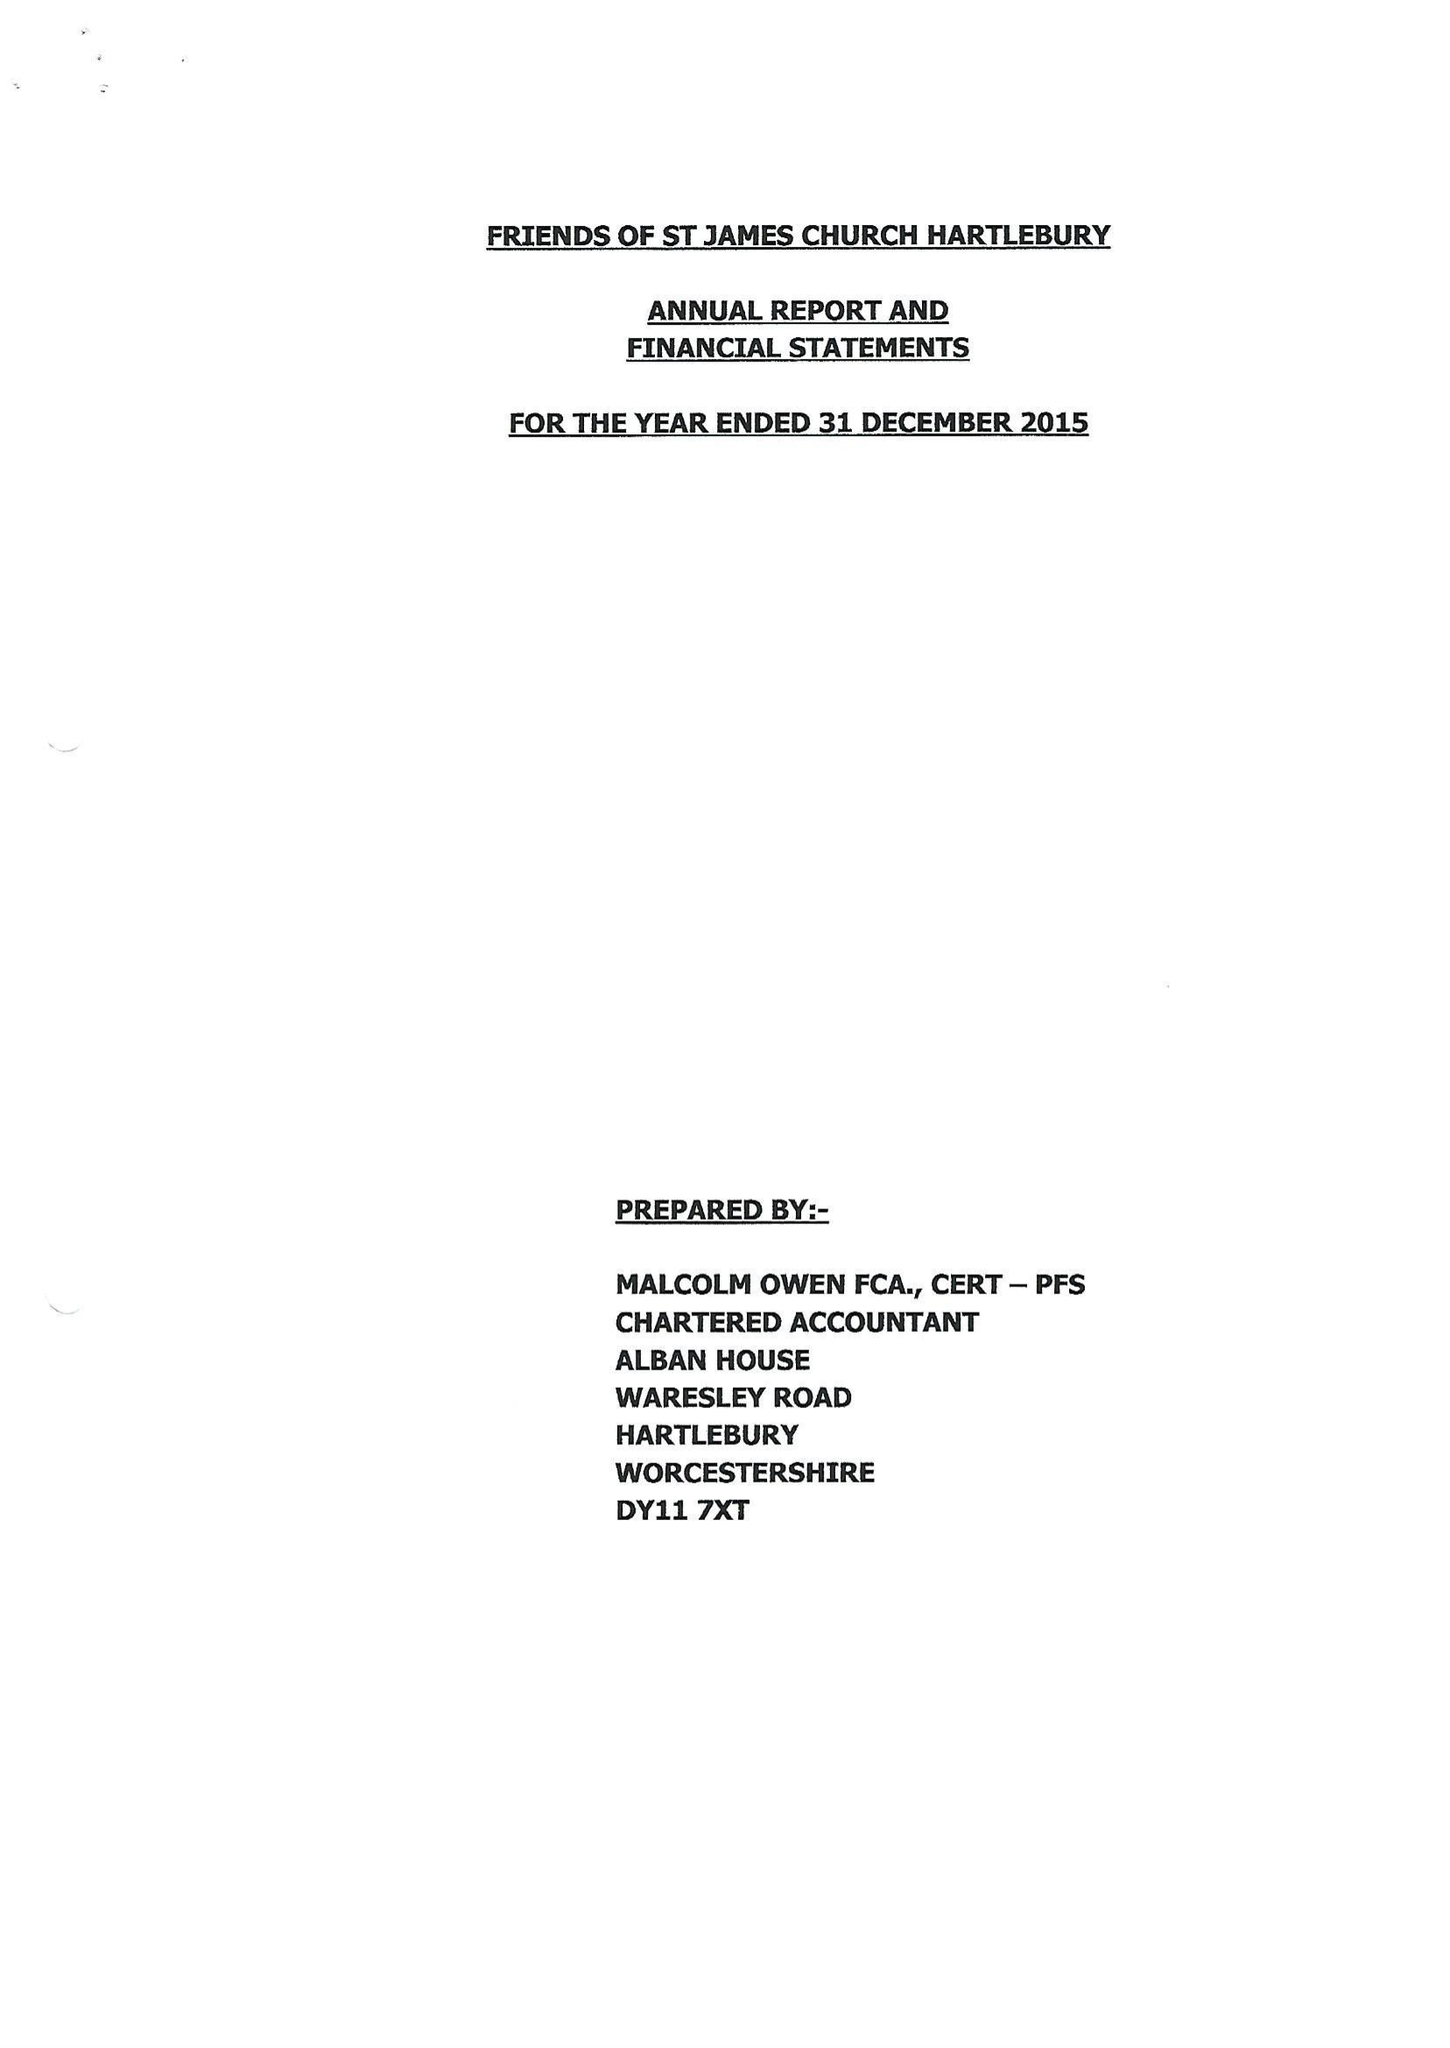What is the value for the spending_annually_in_british_pounds?
Answer the question using a single word or phrase. 44861.00 